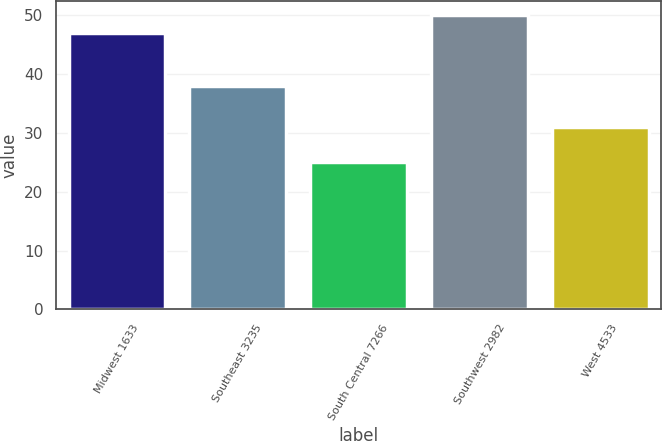Convert chart to OTSL. <chart><loc_0><loc_0><loc_500><loc_500><bar_chart><fcel>Midwest 1633<fcel>Southeast 3235<fcel>South Central 7266<fcel>Southwest 2982<fcel>West 4533<nl><fcel>47<fcel>38<fcel>25<fcel>50<fcel>31<nl></chart> 